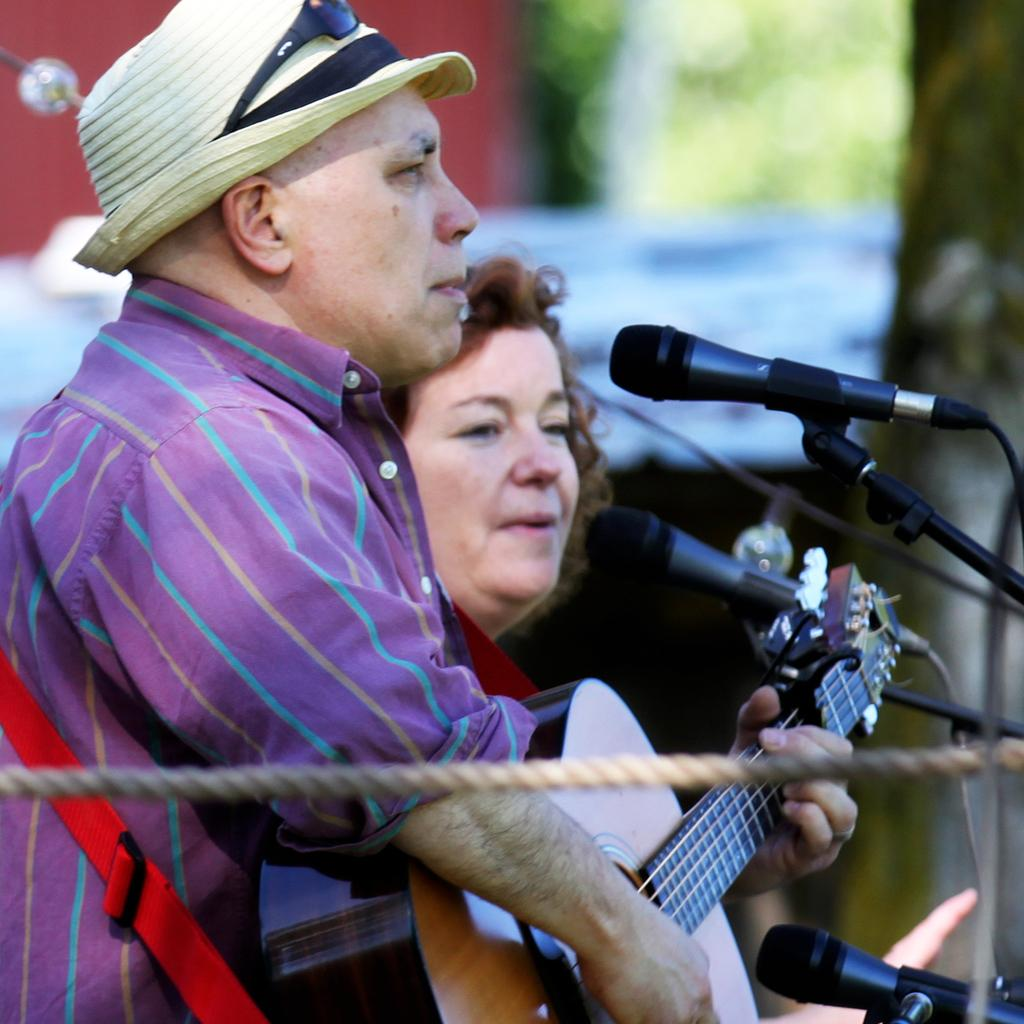What is the man on the left side of the image doing? The man is holding a guitar in his hand and singing on a microphone. Who is standing beside the man? There is a woman standing beside the man. What is the woman doing? The woman is also singing. How many mice can be seen running around the stage in the image? There are no mice present in the image; it features a man and a woman singing with a guitar. 